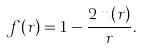<formula> <loc_0><loc_0><loc_500><loc_500>f ( r ) = 1 - \frac { 2 m ( r ) } { r } .</formula> 